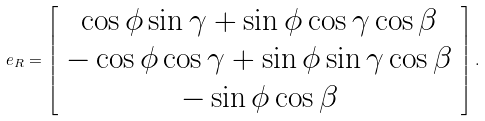Convert formula to latex. <formula><loc_0><loc_0><loc_500><loc_500>e _ { R } = \left [ \begin{array} { c } \cos \phi \sin \gamma + \sin \phi \cos \gamma \cos \beta \\ - \cos \phi \cos \gamma + \sin \phi \sin \gamma \cos \beta \\ - \sin \phi \cos \beta \end{array} \right ] .</formula> 